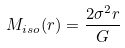Convert formula to latex. <formula><loc_0><loc_0><loc_500><loc_500>M _ { i s o } ( r ) = \frac { 2 \sigma ^ { 2 } r } { G }</formula> 